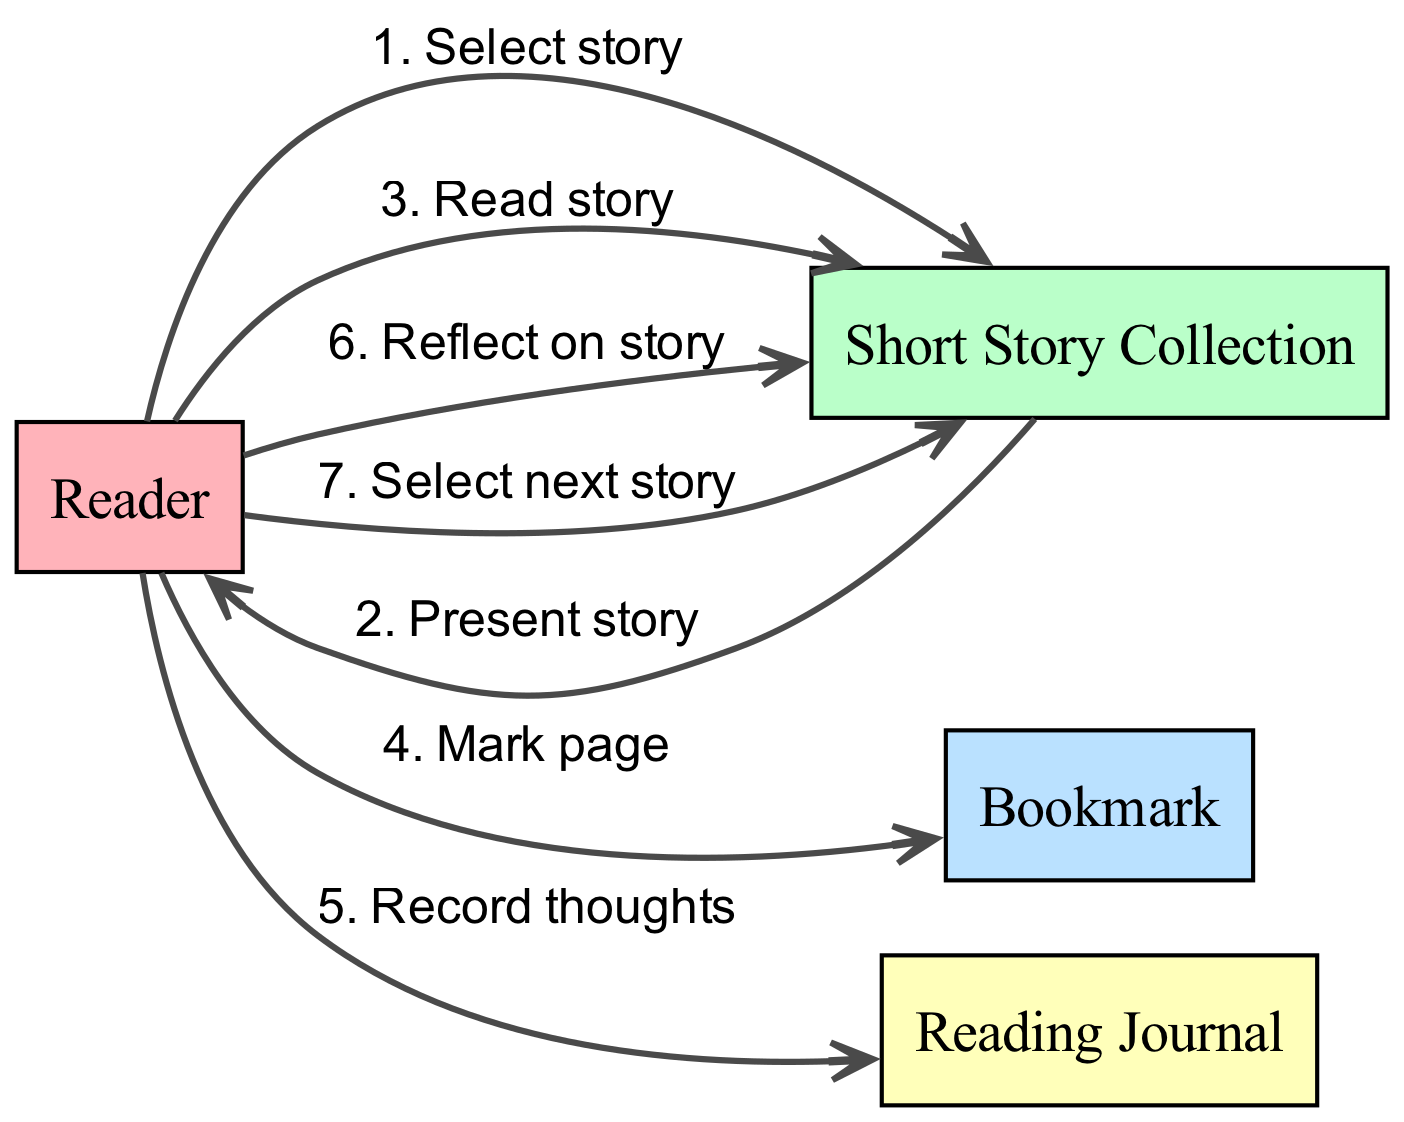What is the first action taken by the Reader? The sequence starts with the Reader selecting a story from the Short Story Collection, which is the initial action depicted in the diagram.
Answer: Select story How many actors are represented in the diagram? There are four actors shown in the diagram: Reader, Short Story Collection, Bookmark, and Reading Journal.
Answer: Four Which action follows after the Reader records thoughts? After the Reader records thoughts, the next action is reflecting on the story within the Short Story Collection, as indicated by the flow of actions in the sequence diagram.
Answer: Reflect on story What action does the Reader perform before selecting the next story? The Reader reflects on the current story before selecting the next one, confirming the sequence of actions leading up to the next selection.
Answer: Reflect on story Which actor does the Reader interact with to mark the page? The Reader interacts with the Bookmark to mark the current page, showing a relationship in the flow where the Reader needs to keep track of their place.
Answer: Bookmark How many edges are present in the diagram? The diagram contains six edges, each representing an action taken by the Reader in the context of the reading journey as they navigate through the anthology.
Answer: Six Which action is performed after reading a story? After reading a story, the Reader marks the page, indicating a sequential step in the journey that helps organize their reading experience.
Answer: Mark page What is the relationship between Reader and Reading Journal? The relationship is that the Reader records thoughts in the Reading Journal, displaying the Reader's engagement and reflection as they process the stories read.
Answer: Record thoughts What describes the last action in the sequence? The last action depicted is selecting the next story from the Short Story Collection, which implies a continuous engagement with the material and a cyclic nature to the reading journey.
Answer: Select next story 